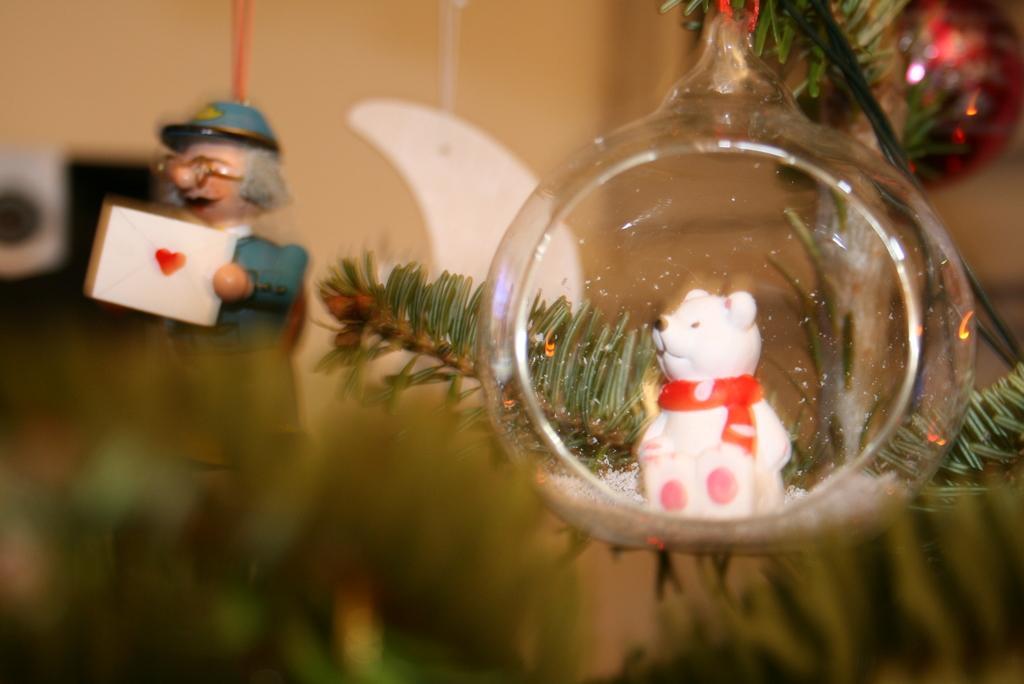How would you summarize this image in a sentence or two? In this picture I can see a Christmas tree on which I can see toys. On the right side I can see round shaped glass in which I can see a white color teddy bear toy and some other toys. 